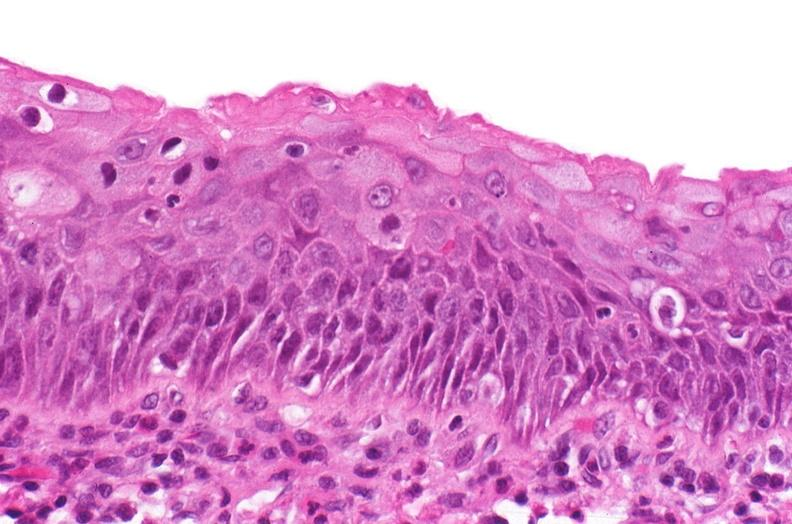what is present?
Answer the question using a single word or phrase. Urinary 